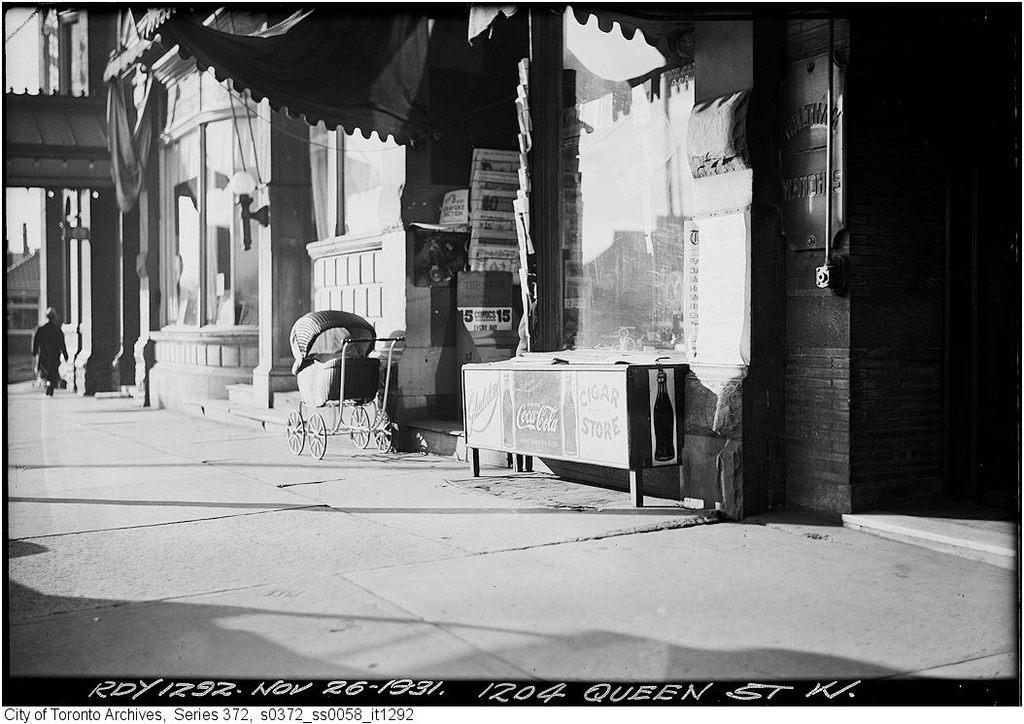What is the main object in the image? There is a trolley in the image. Can you describe the person in the image? There is a person in the image. What is the purpose of the canvas cloth in the image? The canvas cloth is in the image. What items can be seen on the table in the image? There are books on the table in the image. What type of furniture is present in the image? There is a table in the image. What is the surrounding environment like in the image? There are walls in the image, and the sky is visible, suggesting an indoor or semi-enclosed space. What type of lighting is present in the image? There is an electric light in the image. What type of structure is present in the image? There is a building in the image. What type of infrastructure is present in the image? There is a pipeline in the image. How many feet are visible in the image? There are no feet present in the image. What type of street can be seen in the image? There is no street present in the image. 